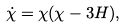<formula> <loc_0><loc_0><loc_500><loc_500>\dot { \chi } = \chi ( \chi - 3 H ) ,</formula> 